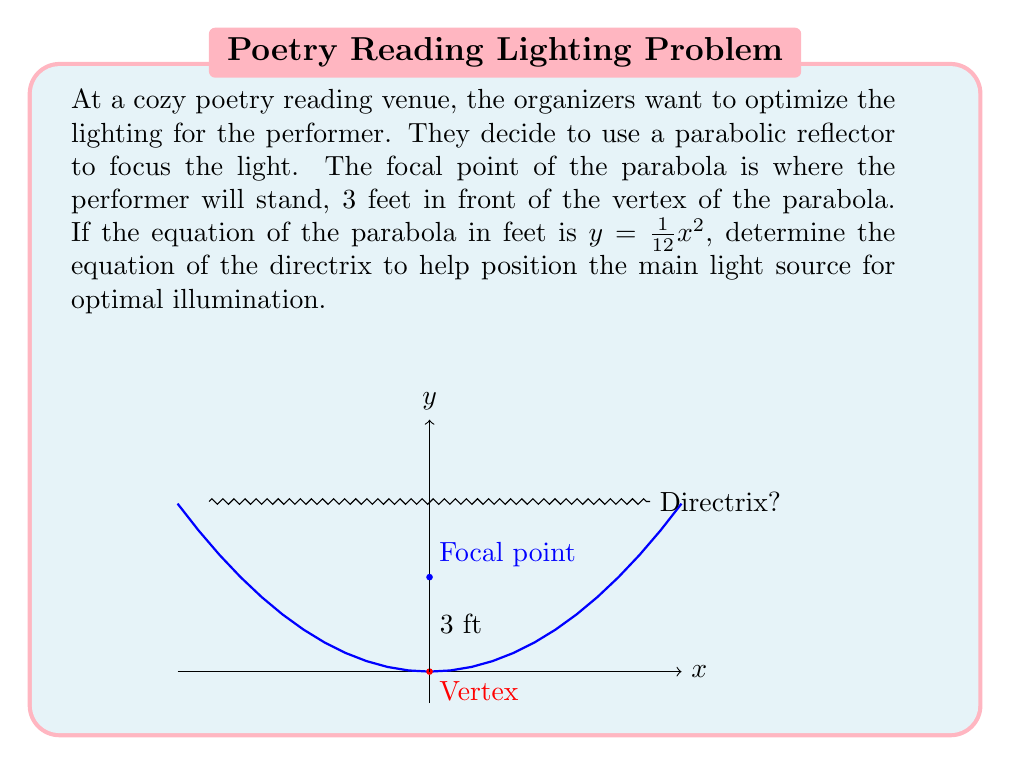Could you help me with this problem? Let's approach this step-by-step:

1) The general equation of a parabola with vertex at the origin is:
   $y = ax^2$, where $a = \frac{1}{4p}$ and $p$ is the focal length.

2) In our case, $y = \frac{1}{12}x^2$, so $a = \frac{1}{12}$.

3) We can find $p$ using the relation $a = \frac{1}{4p}$:
   $\frac{1}{12} = \frac{1}{4p}$
   $p = 3$

4) This confirms that the focal point is 3 feet above the vertex, as stated in the question.

5) For a parabola with vertex at the origin, the directrix is given by the equation:
   $y = -p$

6) Therefore, the equation of the directrix is:
   $y = -3$

7) However, we need to interpret this in the context of the problem. The directrix is 3 feet below the vertex, which means the main light source should be positioned 6 feet in front of the performer for optimal illumination (3 feet from the vertex to the focal point, and another 3 feet from the vertex to the directrix).
Answer: $y = -3$ 